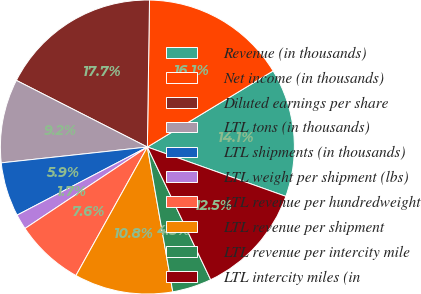<chart> <loc_0><loc_0><loc_500><loc_500><pie_chart><fcel>Revenue (in thousands)<fcel>Net income (in thousands)<fcel>Diluted earnings per share<fcel>LTL tons (in thousands)<fcel>LTL shipments (in thousands)<fcel>LTL weight per shipment (lbs)<fcel>LTL revenue per hundredweight<fcel>LTL revenue per shipment<fcel>LTL revenue per intercity mile<fcel>LTL intercity miles (in<nl><fcel>14.11%<fcel>16.11%<fcel>17.74%<fcel>9.21%<fcel>5.95%<fcel>1.68%<fcel>7.58%<fcel>10.84%<fcel>4.32%<fcel>12.47%<nl></chart> 